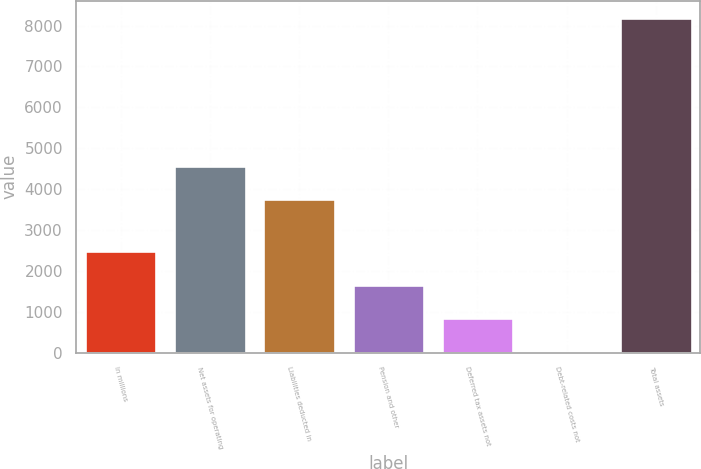Convert chart to OTSL. <chart><loc_0><loc_0><loc_500><loc_500><bar_chart><fcel>In millions<fcel>Net assets for operating<fcel>Liabilities deducted in<fcel>Pension and other<fcel>Deferred tax assets not<fcel>Debt-related costs not<fcel>Total assets<nl><fcel>2476.7<fcel>4575.9<fcel>3759<fcel>1659.8<fcel>842.9<fcel>26<fcel>8195<nl></chart> 